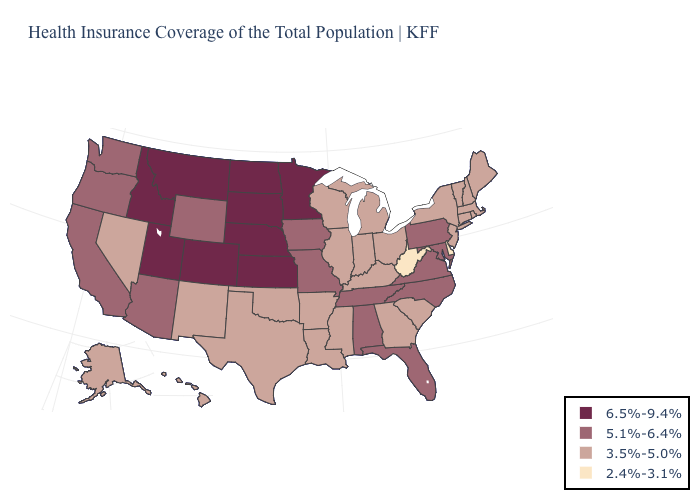Does the map have missing data?
Write a very short answer. No. What is the value of Maryland?
Answer briefly. 5.1%-6.4%. How many symbols are there in the legend?
Answer briefly. 4. What is the lowest value in states that border Tennessee?
Keep it brief. 3.5%-5.0%. Name the states that have a value in the range 2.4%-3.1%?
Short answer required. Delaware, West Virginia. What is the value of Arkansas?
Short answer required. 3.5%-5.0%. What is the highest value in the South ?
Short answer required. 5.1%-6.4%. Which states have the highest value in the USA?
Keep it brief. Colorado, Idaho, Kansas, Minnesota, Montana, Nebraska, North Dakota, South Dakota, Utah. Which states have the lowest value in the USA?
Concise answer only. Delaware, West Virginia. Does Kansas have the lowest value in the MidWest?
Be succinct. No. Among the states that border Arkansas , does Mississippi have the lowest value?
Be succinct. Yes. Which states hav the highest value in the MidWest?
Short answer required. Kansas, Minnesota, Nebraska, North Dakota, South Dakota. What is the value of Texas?
Write a very short answer. 3.5%-5.0%. Does New Jersey have the same value as Rhode Island?
Give a very brief answer. Yes. Does Indiana have the highest value in the MidWest?
Write a very short answer. No. 